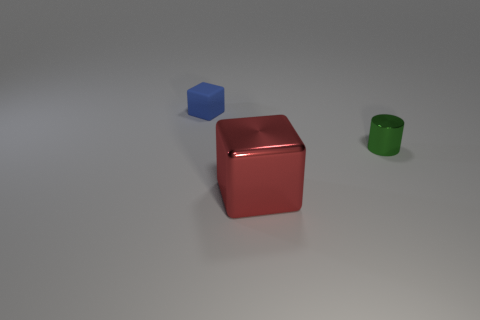Is there anything else that is the same size as the red shiny object?
Provide a short and direct response. No. What number of things are things in front of the tiny green cylinder or small yellow balls?
Your response must be concise. 1. There is a thing that is the same size as the green cylinder; what is its shape?
Your response must be concise. Cube. There is a thing that is right of the red cube; is it the same size as the thing left of the shiny block?
Your response must be concise. Yes. What is the color of the big object that is the same material as the green cylinder?
Keep it short and to the point. Red. Is the thing that is to the left of the big red metallic thing made of the same material as the thing on the right side of the big red metal thing?
Make the answer very short. No. Are there any red metallic things of the same size as the shiny cylinder?
Your answer should be very brief. No. What is the size of the thing to the right of the block that is right of the small blue rubber block?
Provide a short and direct response. Small. What number of small things have the same color as the shiny cylinder?
Offer a terse response. 0. There is a metal object that is in front of the object on the right side of the metal block; what is its shape?
Ensure brevity in your answer.  Cube. 